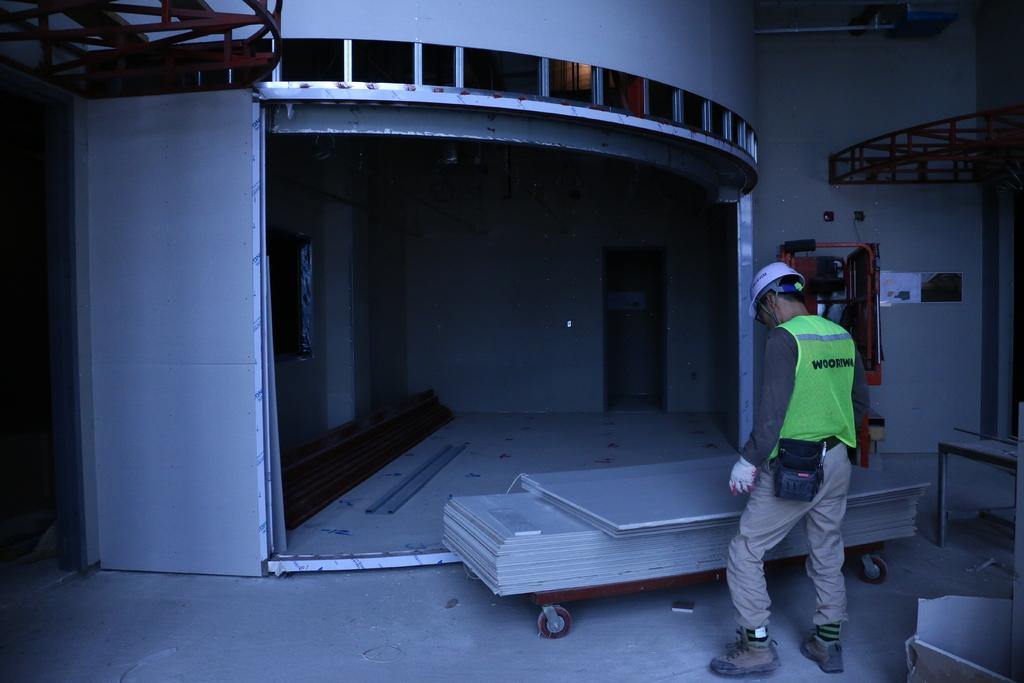What is the main subject of the image? There is a man standing in the image. What is in front of the man? There are objects on a trolley in front of the man. What can be seen in the background of the image? There is a door to a wall in the background of the image. What is located to the right of the man? There are machines to the the right of the man. Can you see a rabbit playing on the bridge in the image? There is no bridge or rabbit present in the image. 